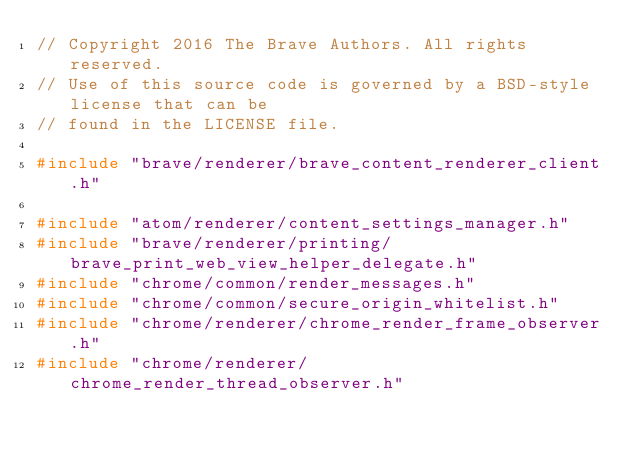Convert code to text. <code><loc_0><loc_0><loc_500><loc_500><_C++_>// Copyright 2016 The Brave Authors. All rights reserved.
// Use of this source code is governed by a BSD-style license that can be
// found in the LICENSE file.

#include "brave/renderer/brave_content_renderer_client.h"

#include "atom/renderer/content_settings_manager.h"
#include "brave/renderer/printing/brave_print_web_view_helper_delegate.h"
#include "chrome/common/render_messages.h"
#include "chrome/common/secure_origin_whitelist.h"
#include "chrome/renderer/chrome_render_frame_observer.h"
#include "chrome/renderer/chrome_render_thread_observer.h"</code> 